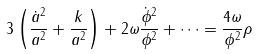Convert formula to latex. <formula><loc_0><loc_0><loc_500><loc_500>3 \left ( \frac { \dot { a } ^ { 2 } } { a ^ { 2 } } + \frac { k } { a ^ { 2 } } \right ) + 2 \omega \frac { \dot { \phi } ^ { 2 } } { \phi ^ { 2 } } + \dots = \frac { 4 \omega } { \phi ^ { 2 } } \rho</formula> 